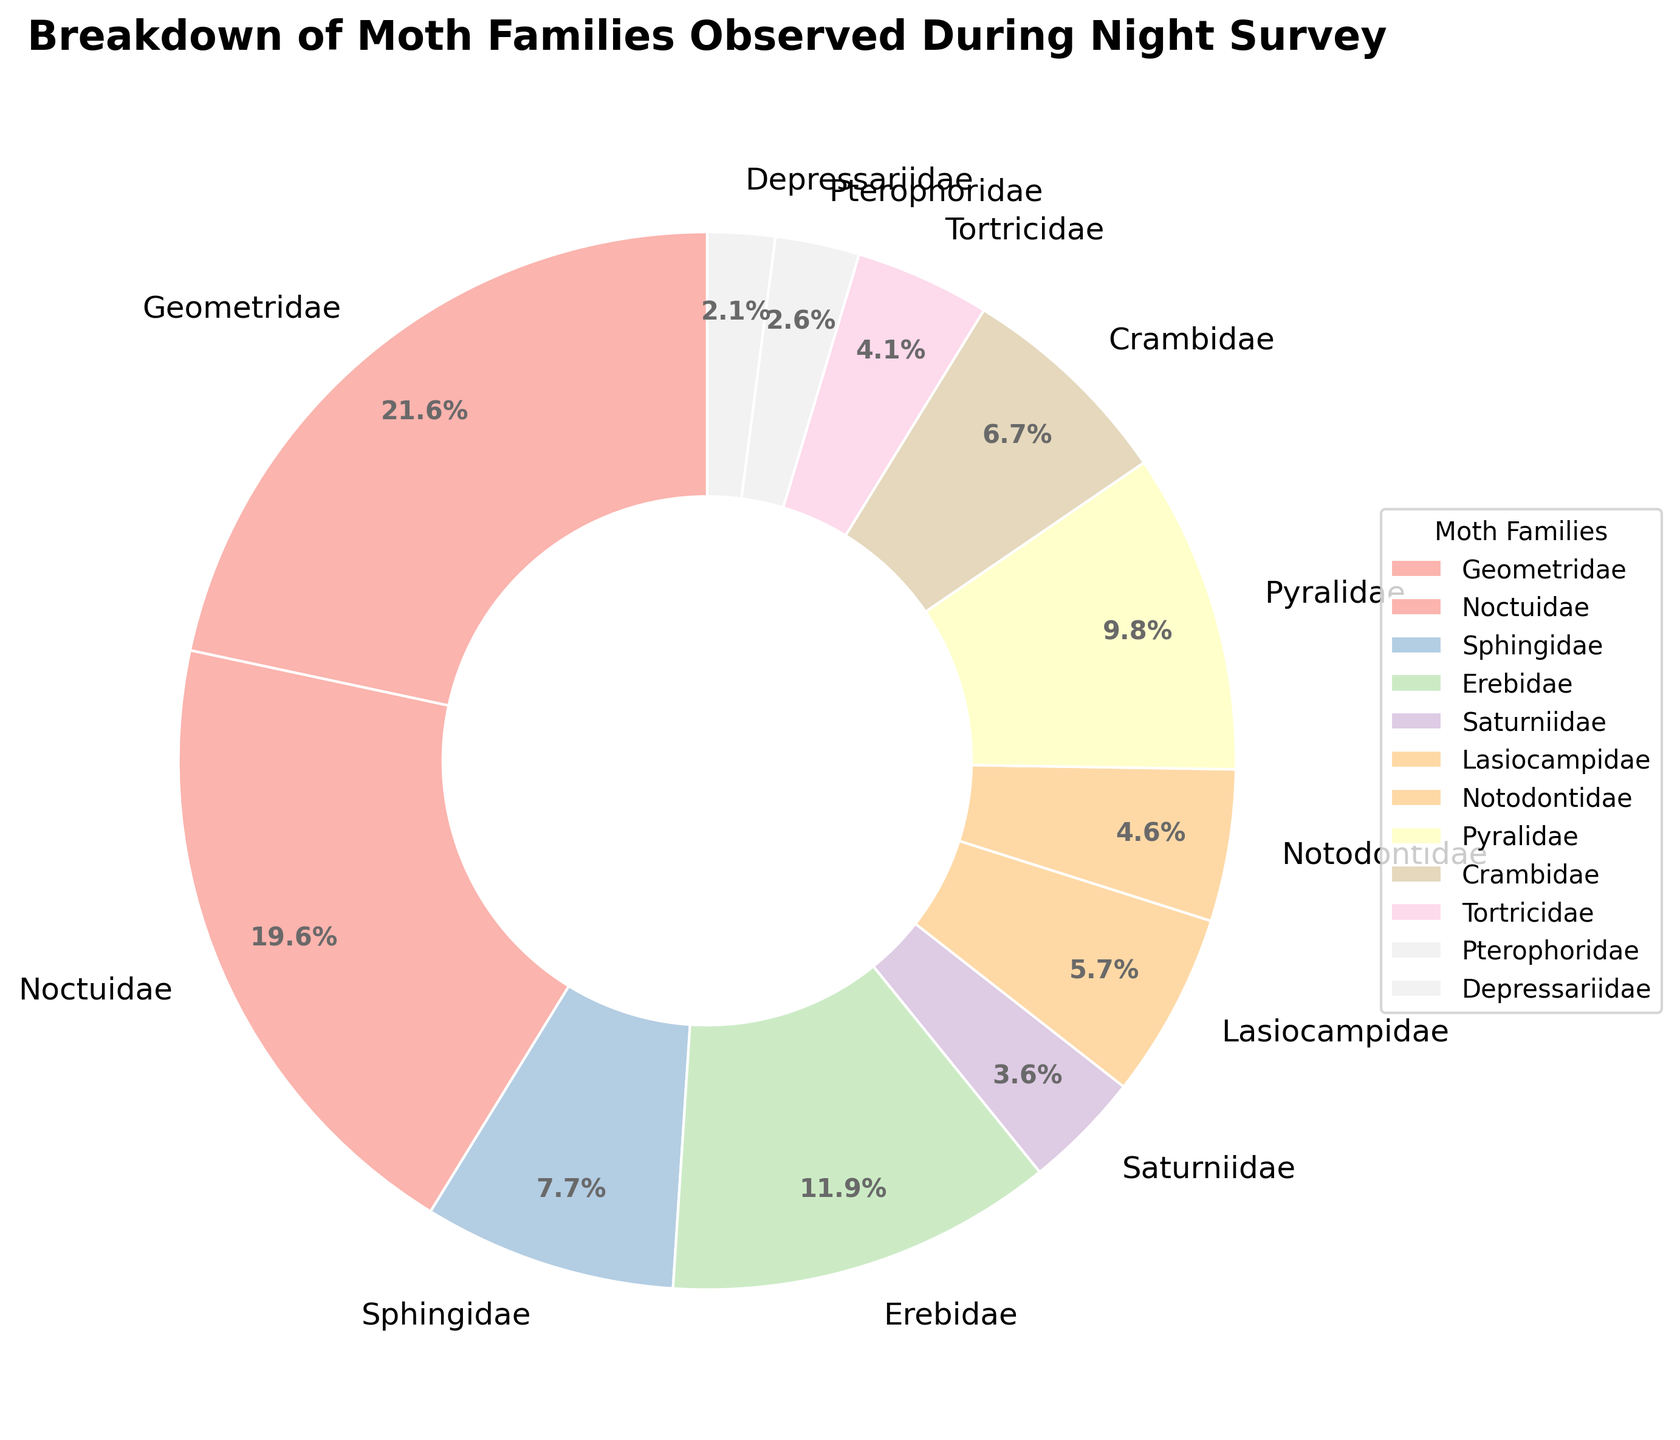Which moth family has the highest count? Look at the pie chart for the segment with the largest percentage. Geometridae has the largest segment.
Answer: Geometridae How many moth families have observed counts greater than 20? Identify the segments with percentages that correspond to counts greater than 20: Geometridae (42), Noctuidae (38), and Erebidae (23).
Answer: 3 What is the combined percentage for Sphingidae and Saturniidae? Check the pie chart percentages for Sphingidae (8.0%) and Saturniidae (3.7%) and add them up.
Answer: 11.7% Which family has a lower count, Notodontidae or Tortricidae? Compare the segments for Notodontidae and Tortricidae; Notodontidae is smaller with a 4.8% share compared to 4.3% for Tortricidae.
Answer: Tortricidae How much larger is the count of Geometridae compared to Lasiocampidae? Subtract the count of Lasiocampidae (11) from Geometridae (42).
Answer: 31 What is the percentage difference between the largest and the smallest observed families? Geometridae (29.8%) is the largest and Depressariidae (2.8%) is the smallest; subtract the smaller percentage from the larger percentage.
Answer: 27.0% Which families have counts less than 10? Look for the segments with percentages corresponding to counts below 10: Tortricidae, Pterophoridae, and Depressariidae.
Answer: Tortricidae, Pterophoridae, Depressariidae Is the count of Pyralidae greater than the combined counts of Pterophoridae and Depressariidae? Compare the count of Pyralidae (19) with the total of Pterophoridae (5) and Depressariidae (4) which is 9.
Answer: Yes What's the total count of moths observed? Sum the counts of all families together: 42+38+15+23+7+11+9+19+13+8+5+4
Answer: 194 What is the average count of moths in the families with observed counts below 10? Identify the counts less than 10: Notodontidae (9), Tortricidae (8), Pterophoridae (5), Depressariidae (4), sum these (9+8+5+4=26), then divide by the number of families (4).
Answer: 6.5 